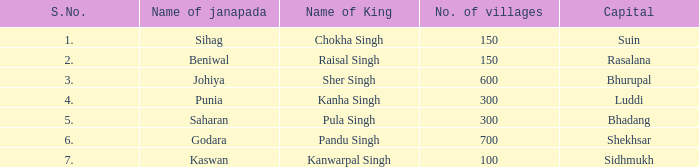What ruler has an s. number exceeding 1 and a total of 600 settlements? Sher Singh. 